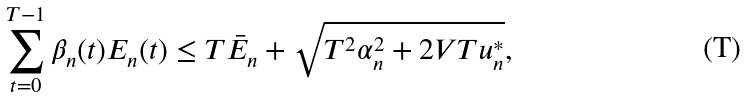Convert formula to latex. <formula><loc_0><loc_0><loc_500><loc_500>\sum _ { t = 0 } ^ { T - 1 } \beta _ { n } ( t ) E _ { n } ( t ) \leq T \bar { E } _ { n } + \sqrt { T ^ { 2 } \alpha _ { n } ^ { 2 } + 2 V T u _ { n } ^ { * } } ,</formula> 